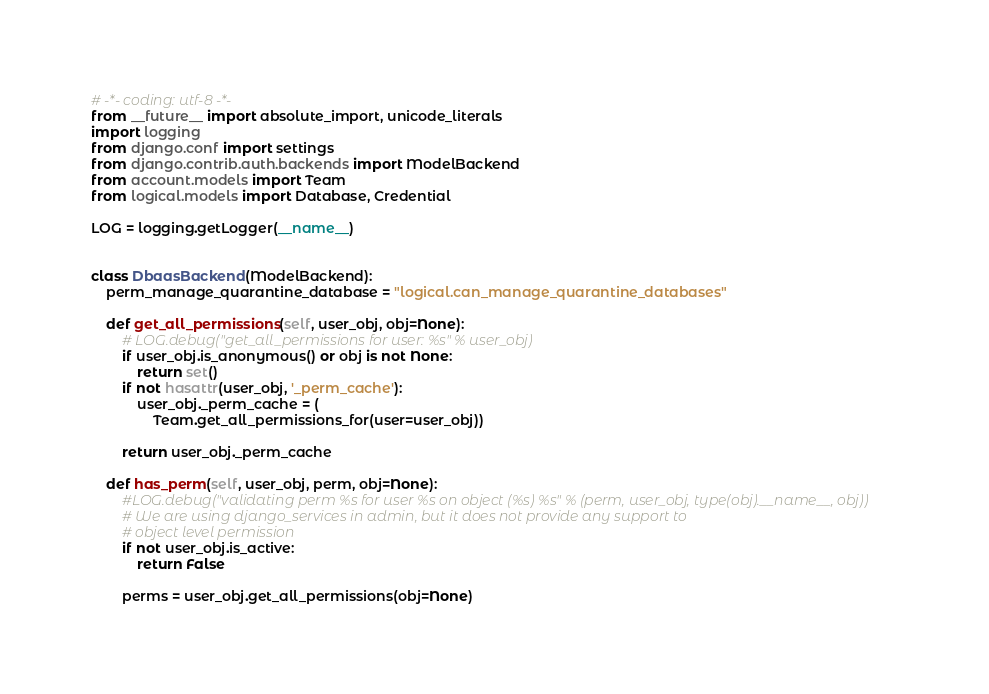<code> <loc_0><loc_0><loc_500><loc_500><_Python_># -*- coding: utf-8 -*-
from __future__ import absolute_import, unicode_literals
import logging
from django.conf import settings
from django.contrib.auth.backends import ModelBackend
from account.models import Team
from logical.models import Database, Credential

LOG = logging.getLogger(__name__)


class DbaasBackend(ModelBackend):
    perm_manage_quarantine_database = "logical.can_manage_quarantine_databases"

    def get_all_permissions(self, user_obj, obj=None):
        # LOG.debug("get_all_permissions for user: %s" % user_obj)
        if user_obj.is_anonymous() or obj is not None:
            return set()
        if not hasattr(user_obj, '_perm_cache'):
            user_obj._perm_cache = (
                Team.get_all_permissions_for(user=user_obj))

        return user_obj._perm_cache

    def has_perm(self, user_obj, perm, obj=None):
        #LOG.debug("validating perm %s for user %s on object (%s) %s" % (perm, user_obj, type(obj).__name__, obj))
        # We are using django_services in admin, but it does not provide any support to
        # object level permission
        if not user_obj.is_active:
            return False

        perms = user_obj.get_all_permissions(obj=None)
</code> 